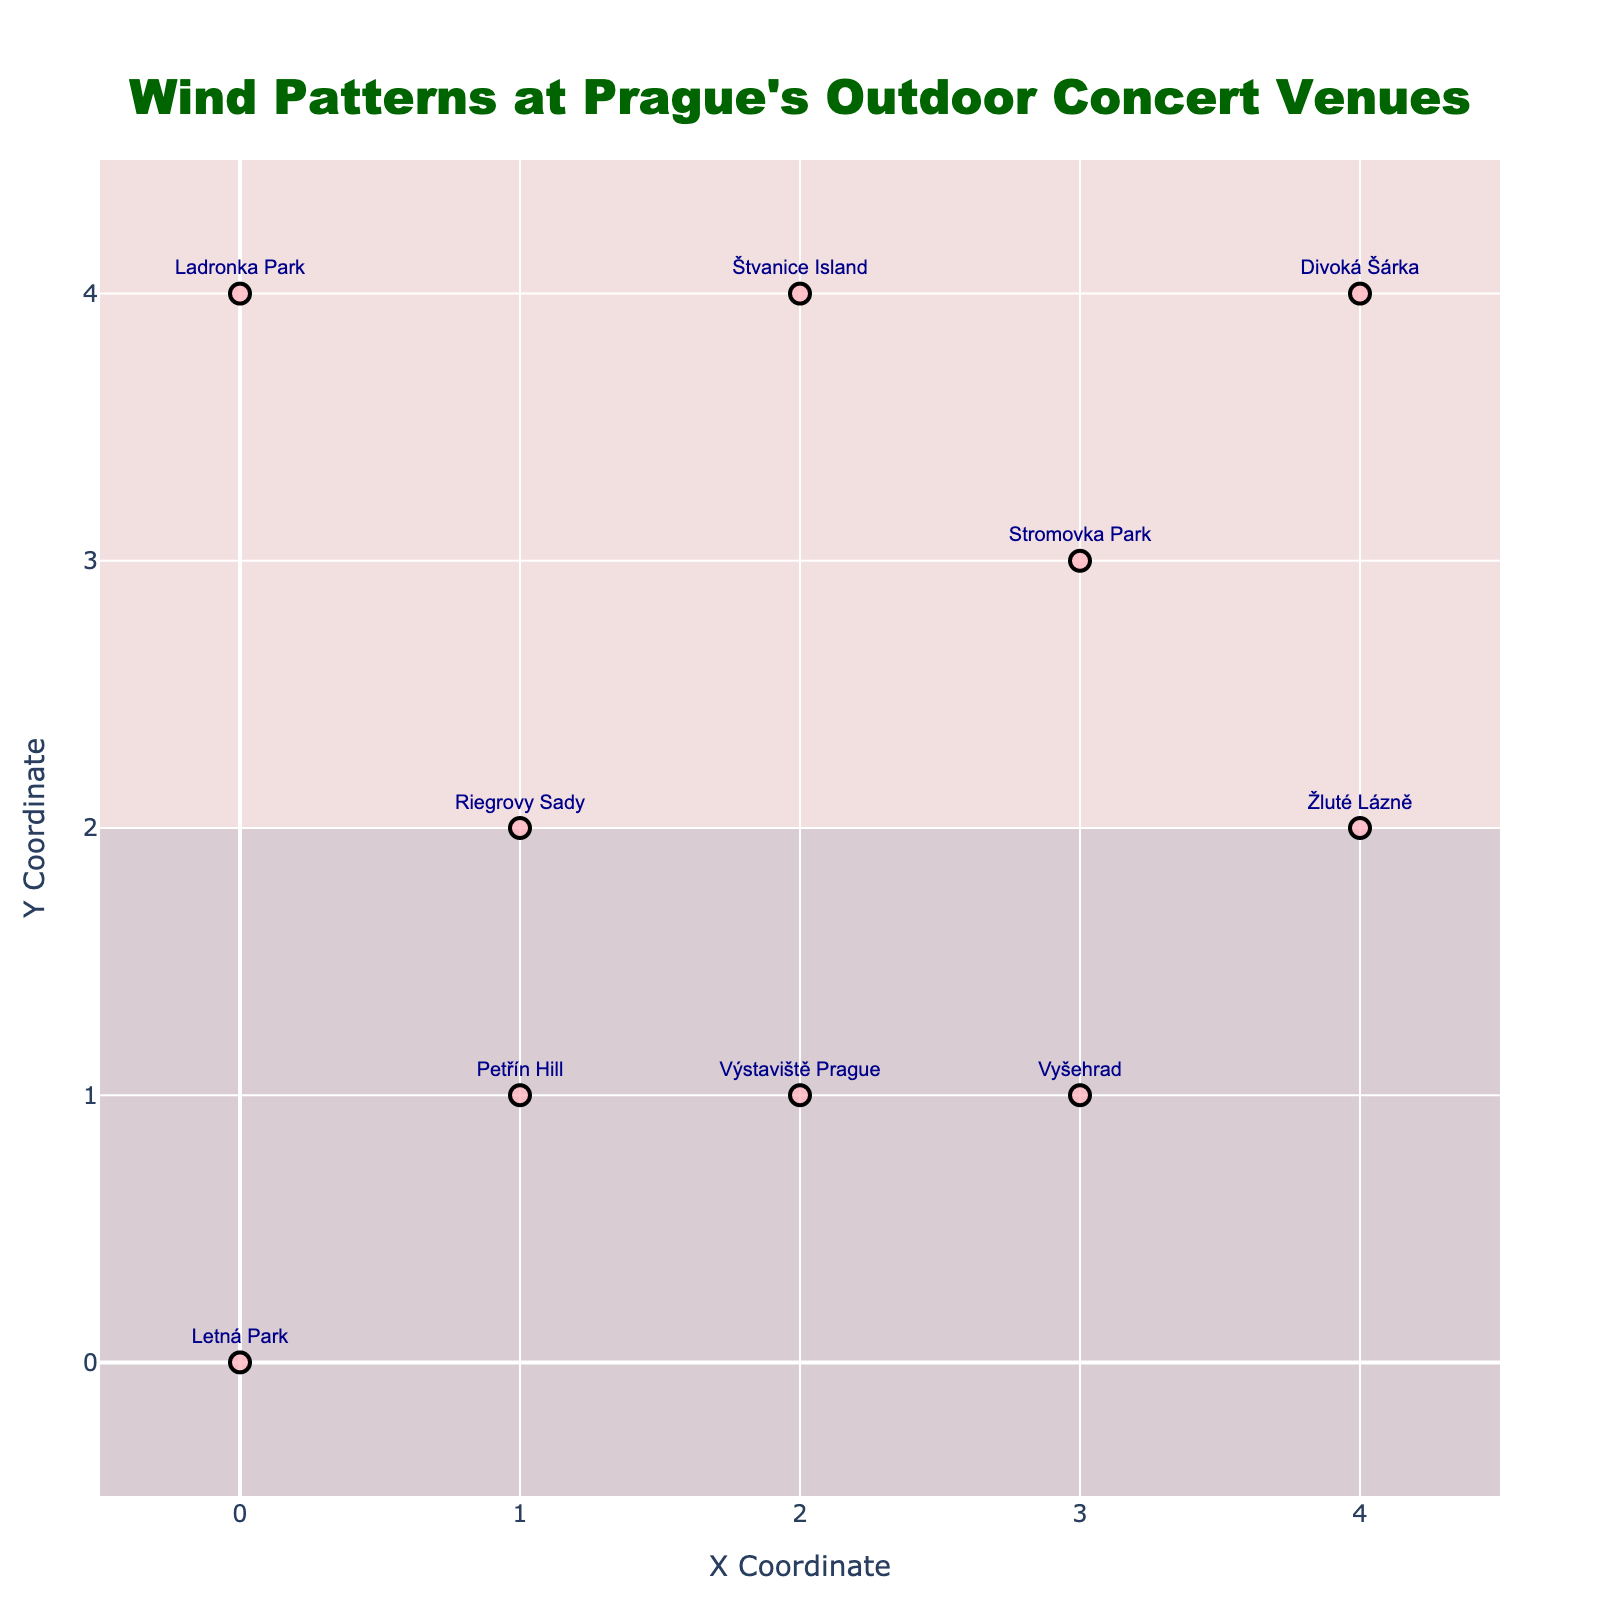What is the title of the plot? The title is displayed at the top center of the plot. It reads "Wind Patterns at Prague's Outdoor Concert Venues".
Answer: "Wind Patterns at Prague's Outdoor Concert Venues" How many data points are visualized on the plot? Each data point corresponds to a venue with its name displayed and a vector showing the wind pattern. Counting these gives 10 data points in total.
Answer: 10 What is the wind direction at Letná Park? The vector originating from the coordinates (0,0) shows that the wind direction is towards the left and slightly upwards. Thus, the wind at Letná Park blows westwards and slightly north.
Answer: West-North Which venue has the strongest wind directly south? Look for the vector pointing directly downwards (south). There is no exact direct south vector, but `Štvanice Island` at (2,4) has a strong southwards component.
Answer: Štvanice Island What is the color theme of the plot’s background? The figure includes three color zones: red at the bottom left, white at the top, and blue at the bottom right, inspired by the Czech flag.
Answer: Czech flag colors Calculate the average wind magnitude at Vyšehrad and Štvanice Island. First, identify the vectors. Vyšehrad has vector (-2, -1) and Štvanice Island has (0, -2). Find the magnitudes using the formula √(u²+v²): Vyšehrad: √(4+1)=√5, Štvanice: √(0+4)=2. The average is (√5 + 2)/2. √5 ≈ 2.24. Thus, (2.24 + 2)/2 = 2.12.
Answer: 2.12 Which venue has the wind blowing in the northeast direction? Look for a vector pointing up and to the right. `Petřín Hill` at (1,1) has the vector (1,1), indicating a northeast direction.
Answer: Petřín Hill Compare the wind directions between `Divoká Šárka` and `Riegrovy Sady`. Which venue experiences a more northern wind direction? Compare the vectors: Divoká Šárka has (2, -2) and Riegrovy Sady has (1, -1). Both have significant south components, but Divoká Šárka has twice the magnitude, making Riegrovy Sady more northern.
Answer: Riegrovy Sady How does the wind at `Ladronka Park` compare with the wind at `Žluté Lázně`? At Ladronka Park (0,4), the vector is (-1, 2), and at Žluté Lázně (4,2), the vector is (-1,2). Both vectors have the same magnitude and direction, indicating equal wind patterns.
Answer: Equal 